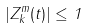<formula> <loc_0><loc_0><loc_500><loc_500>| Z ^ { m } _ { k } ( t ) | \leq 1</formula> 